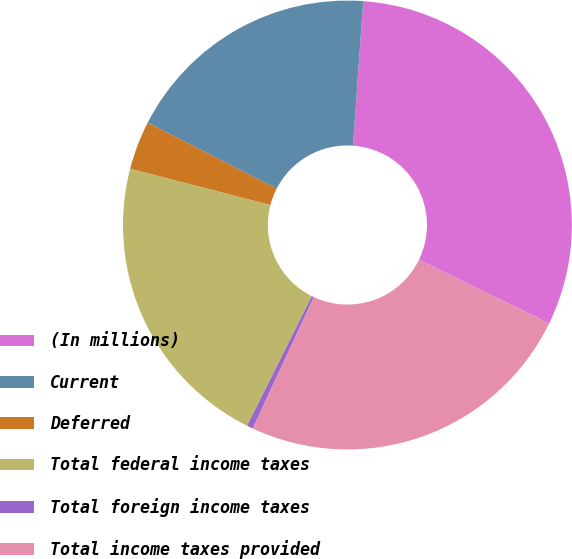Convert chart to OTSL. <chart><loc_0><loc_0><loc_500><loc_500><pie_chart><fcel>(In millions)<fcel>Current<fcel>Deferred<fcel>Total federal income taxes<fcel>Total foreign income taxes<fcel>Total income taxes provided<nl><fcel>31.1%<fcel>18.58%<fcel>3.51%<fcel>21.65%<fcel>0.45%<fcel>24.71%<nl></chart> 